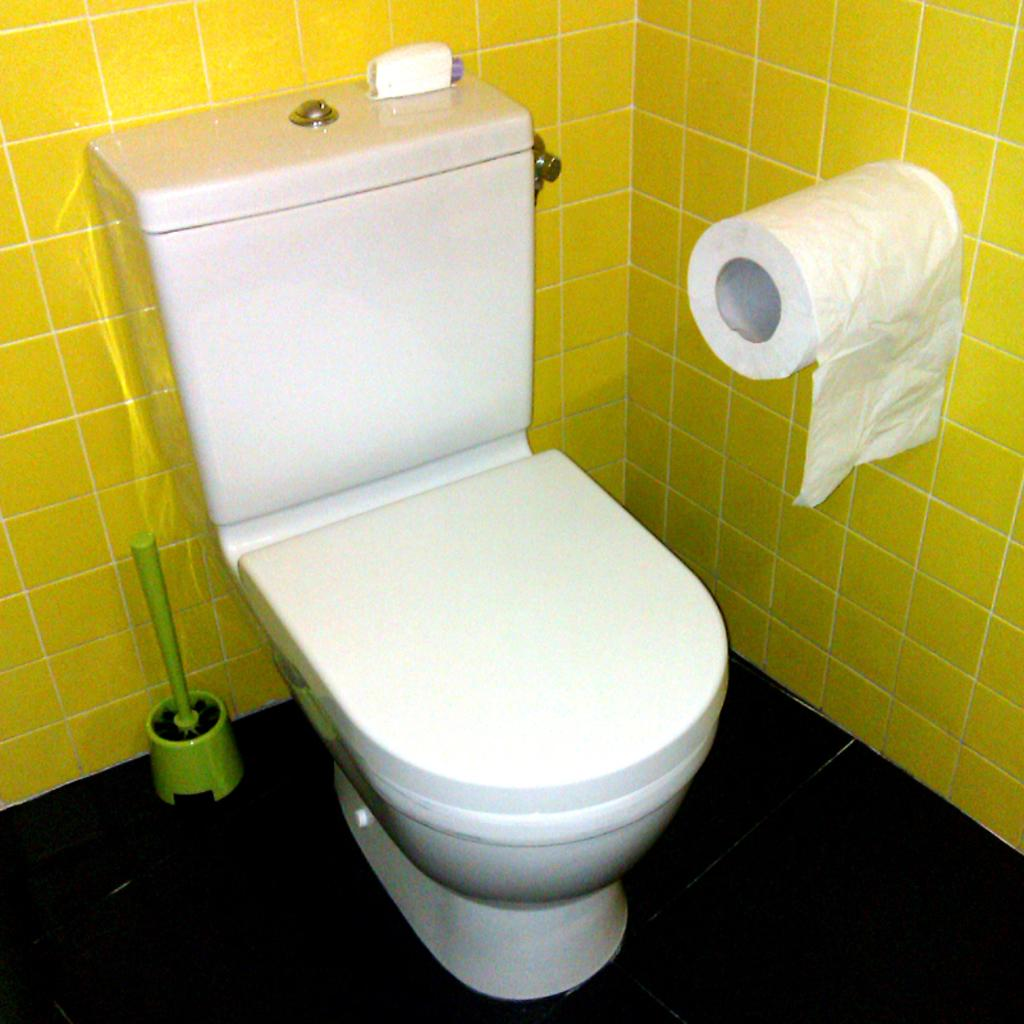What is placed on the floor in the image? There is a toilet seat on the floor. What is on the toilet seat? There is an object on the toilet seat. What is located above the toilet seat? There is a flush tank. What is on the flush tank? There is an object on the flush tank. What can be seen on the right side of the image? There is a tissue roll attached to the wall. What is the scarecrow protesting about in the image? There is no scarecrow present in the image, and therefore no protest can be observed. Can you tell me how the objects on the toilet seat and flush tank are talking to each other in the image? The objects on the toilet seat and flush tank are not capable of talking, as they are inanimate objects. 